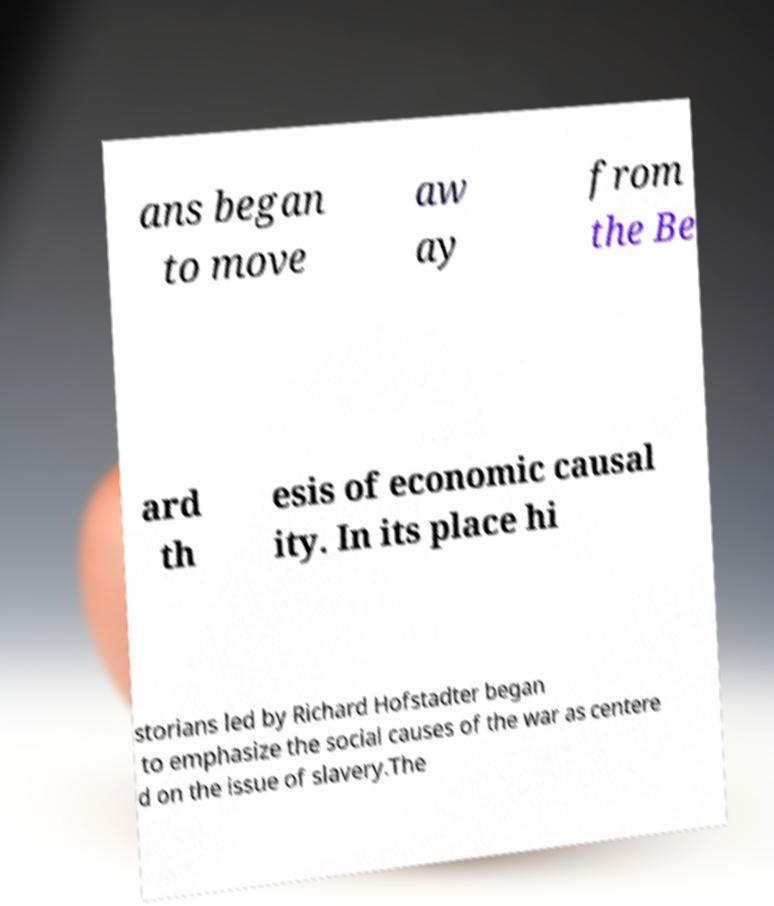For documentation purposes, I need the text within this image transcribed. Could you provide that? ans began to move aw ay from the Be ard th esis of economic causal ity. In its place hi storians led by Richard Hofstadter began to emphasize the social causes of the war as centere d on the issue of slavery.The 